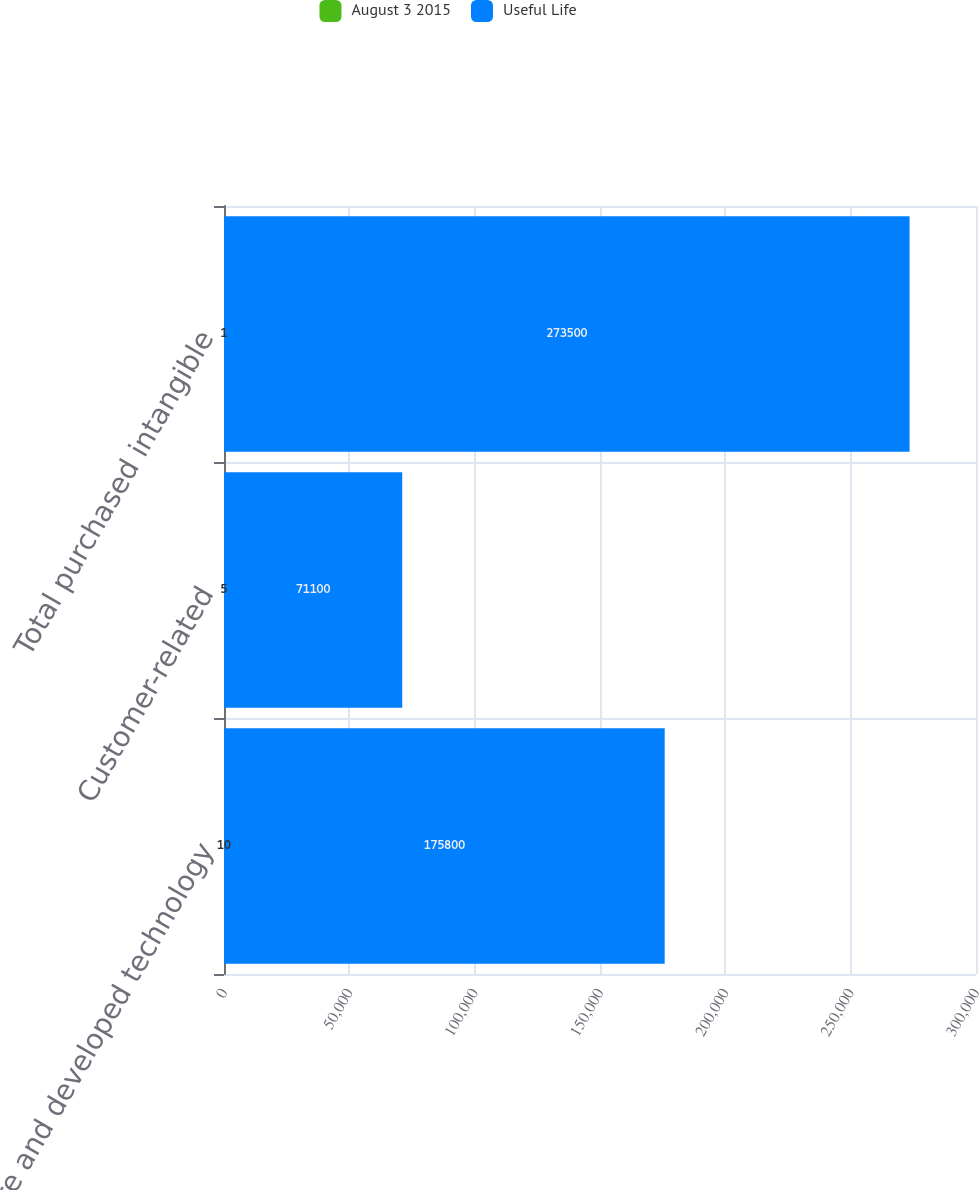<chart> <loc_0><loc_0><loc_500><loc_500><stacked_bar_chart><ecel><fcel>Core and developed technology<fcel>Customer-related<fcel>Total purchased intangible<nl><fcel>August 3 2015<fcel>10<fcel>5<fcel>1<nl><fcel>Useful Life<fcel>175800<fcel>71100<fcel>273500<nl></chart> 